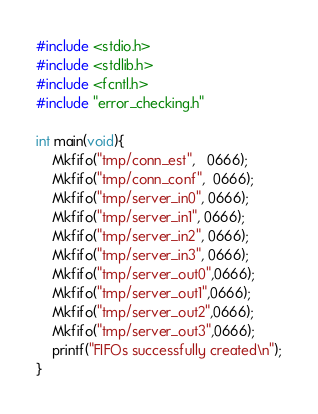Convert code to text. <code><loc_0><loc_0><loc_500><loc_500><_C_>#include <stdio.h>
#include <stdlib.h>
#include <fcntl.h>
#include "error_checking.h"

int main(void){
	Mkfifo("tmp/conn_est",   0666);
	Mkfifo("tmp/conn_conf",  0666);
	Mkfifo("tmp/server_in0", 0666);
	Mkfifo("tmp/server_in1", 0666);
	Mkfifo("tmp/server_in2", 0666);
	Mkfifo("tmp/server_in3", 0666);
	Mkfifo("tmp/server_out0",0666);
	Mkfifo("tmp/server_out1",0666);
	Mkfifo("tmp/server_out2",0666);
	Mkfifo("tmp/server_out3",0666);
	printf("FIFOs successfully created\n");
}
</code> 